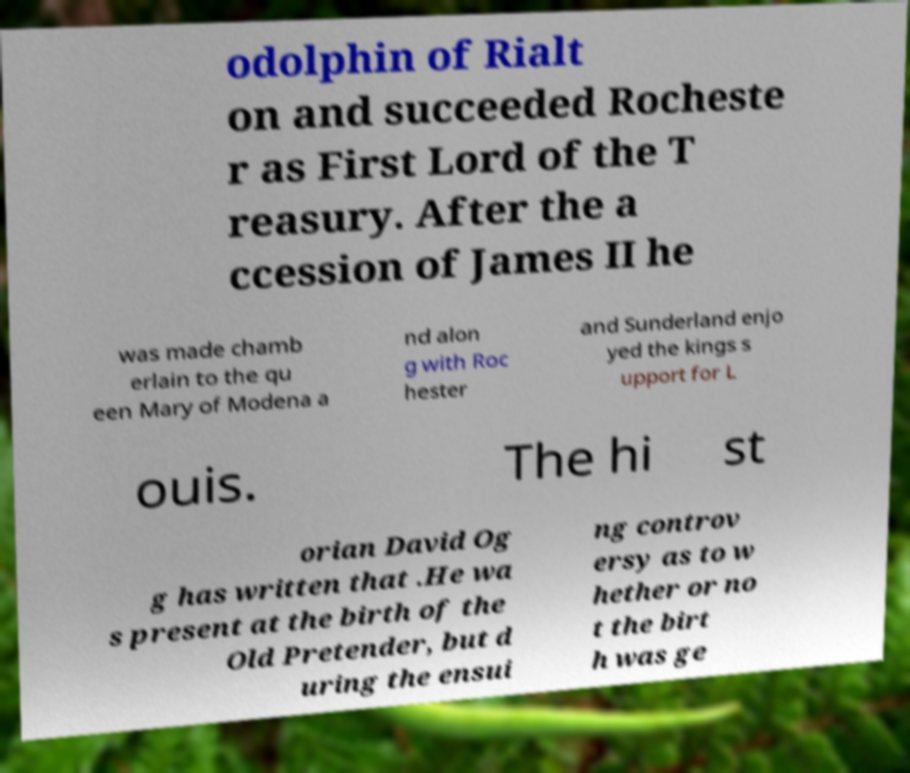Can you accurately transcribe the text from the provided image for me? odolphin of Rialt on and succeeded Rocheste r as First Lord of the T reasury. After the a ccession of James II he was made chamb erlain to the qu een Mary of Modena a nd alon g with Roc hester and Sunderland enjo yed the kings s upport for L ouis. The hi st orian David Og g has written that .He wa s present at the birth of the Old Pretender, but d uring the ensui ng controv ersy as to w hether or no t the birt h was ge 